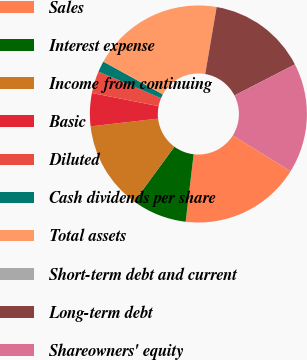<chart> <loc_0><loc_0><loc_500><loc_500><pie_chart><fcel>Sales<fcel>Interest expense<fcel>Income from continuing<fcel>Basic<fcel>Diluted<fcel>Cash dividends per share<fcel>Total assets<fcel>Short-term debt and current<fcel>Long-term debt<fcel>Shareowners' equity<nl><fcel>18.03%<fcel>8.2%<fcel>13.11%<fcel>4.92%<fcel>3.28%<fcel>1.64%<fcel>19.67%<fcel>0.0%<fcel>14.75%<fcel>16.39%<nl></chart> 